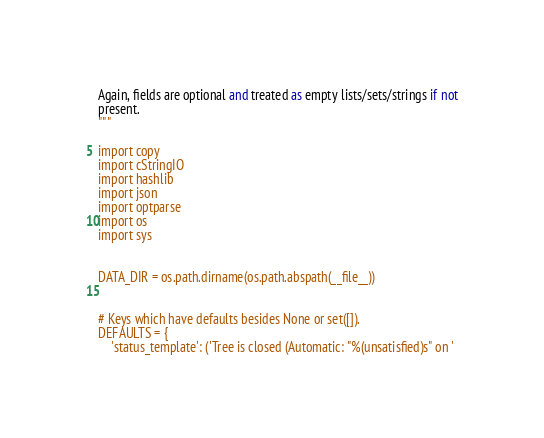Convert code to text. <code><loc_0><loc_0><loc_500><loc_500><_Python_>
Again, fields are optional and treated as empty lists/sets/strings if not
present.
"""

import copy
import cStringIO
import hashlib
import json
import optparse
import os
import sys


DATA_DIR = os.path.dirname(os.path.abspath(__file__))


# Keys which have defaults besides None or set([]).
DEFAULTS = {
    'status_template': ('Tree is closed (Automatic: "%(unsatisfied)s" on '</code> 